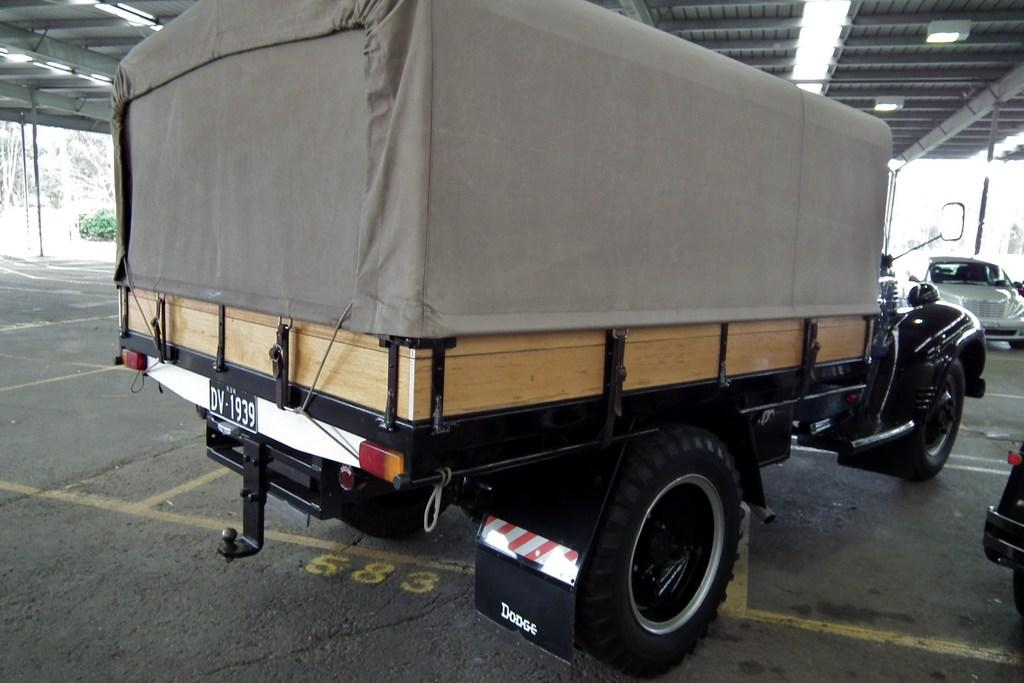What can be found under the shed in the image? There are vehicles parked under the shed. What is located outside the shed? There are plants and trees outside the shed. Can you describe the road in the image? There are markings on the road. What is the tendency of the development at this point in the image? There is no indication of development or any specific point in the image; it primarily features vehicles parked under a shed, plants, trees, and markings on the road. 